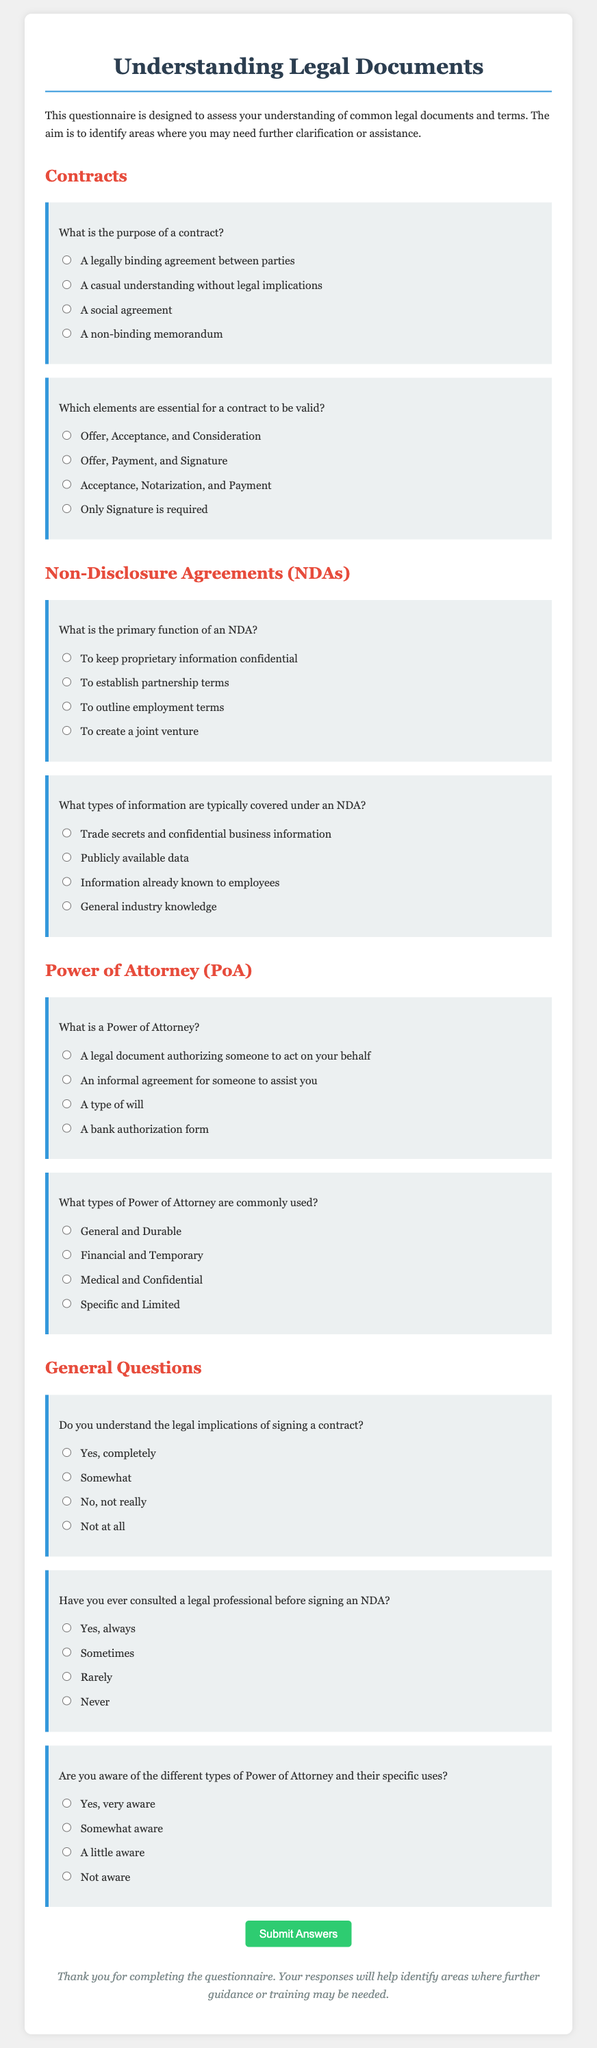What is the title of the document? The title of the document is displayed prominently as the first heading within the rendered document.
Answer: Understanding Legal Documents Questionnaire What is the primary function of an NDA? The primary function of an NDA is clearly defined in the questionnaire under the section about Non-Disclosure Agreements.
Answer: To keep proprietary information confidential What are two elements essential for a contract to be valid? The questionnaire explicitly lists the essential elements for a contract in its options.
Answer: Offer, Acceptance, and Consideration How many types of Power of Attorney are commonly mentioned? The document mentions two types of Power of Attorney in one of its questions about commonly used types.
Answer: General and Durable What response indicates a complete understanding of the legal implications of signing a contract? The questionnaire provides four listening options regarding understanding legal implications, and one option signifies complete understanding.
Answer: Yes, completely Which area of legal documents is addressed first in the questionnaire? The questionnaire is organized into sections, and the first section discusses a specific type of legal document before moving on to others.
Answer: Contracts What is the total number of sections in the questionnaire? The document includes headings for different types of legal documents, and counting them will reveal the total sections.
Answer: Four Have you ever consulted a legal professional before signing an NDA? This question appears in the General Questions section and has specific options relating to past actions regarding NDAs.
Answer: Yes, always What color is used for the background of the container in the rendered document? The background color of the main container is specified in the document's CSS styling.
Answer: White 